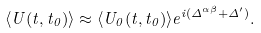Convert formula to latex. <formula><loc_0><loc_0><loc_500><loc_500>\langle U ( t , t _ { 0 } ) \rangle \approx \langle U _ { 0 } ( t , t _ { 0 } ) \rangle e ^ { i ( \Delta ^ { \alpha \beta } + \Delta ^ { \prime } ) } .</formula> 